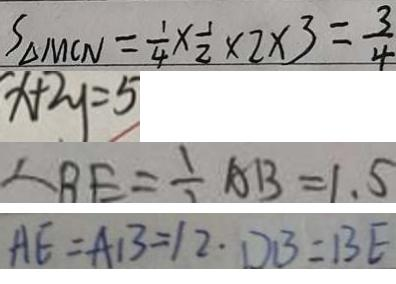Convert formula to latex. <formula><loc_0><loc_0><loc_500><loc_500>S _ { \Delta M C N } = \frac { 1 } { 4 } \times \frac { 1 } { 2 } \times 2 \times 3 = \frac { 3 } { 4 } 
 x + 2 y = 5 
 \therefore B E = \frac { 1 } { 2 } A B = 1 . 5 
 A E = A B = 1 2 \cdot D B = B E</formula> 